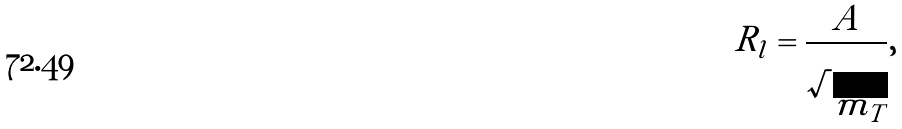Convert formula to latex. <formula><loc_0><loc_0><loc_500><loc_500>R _ { l } = \frac { A } { \sqrt { m _ { T } } } ,</formula> 